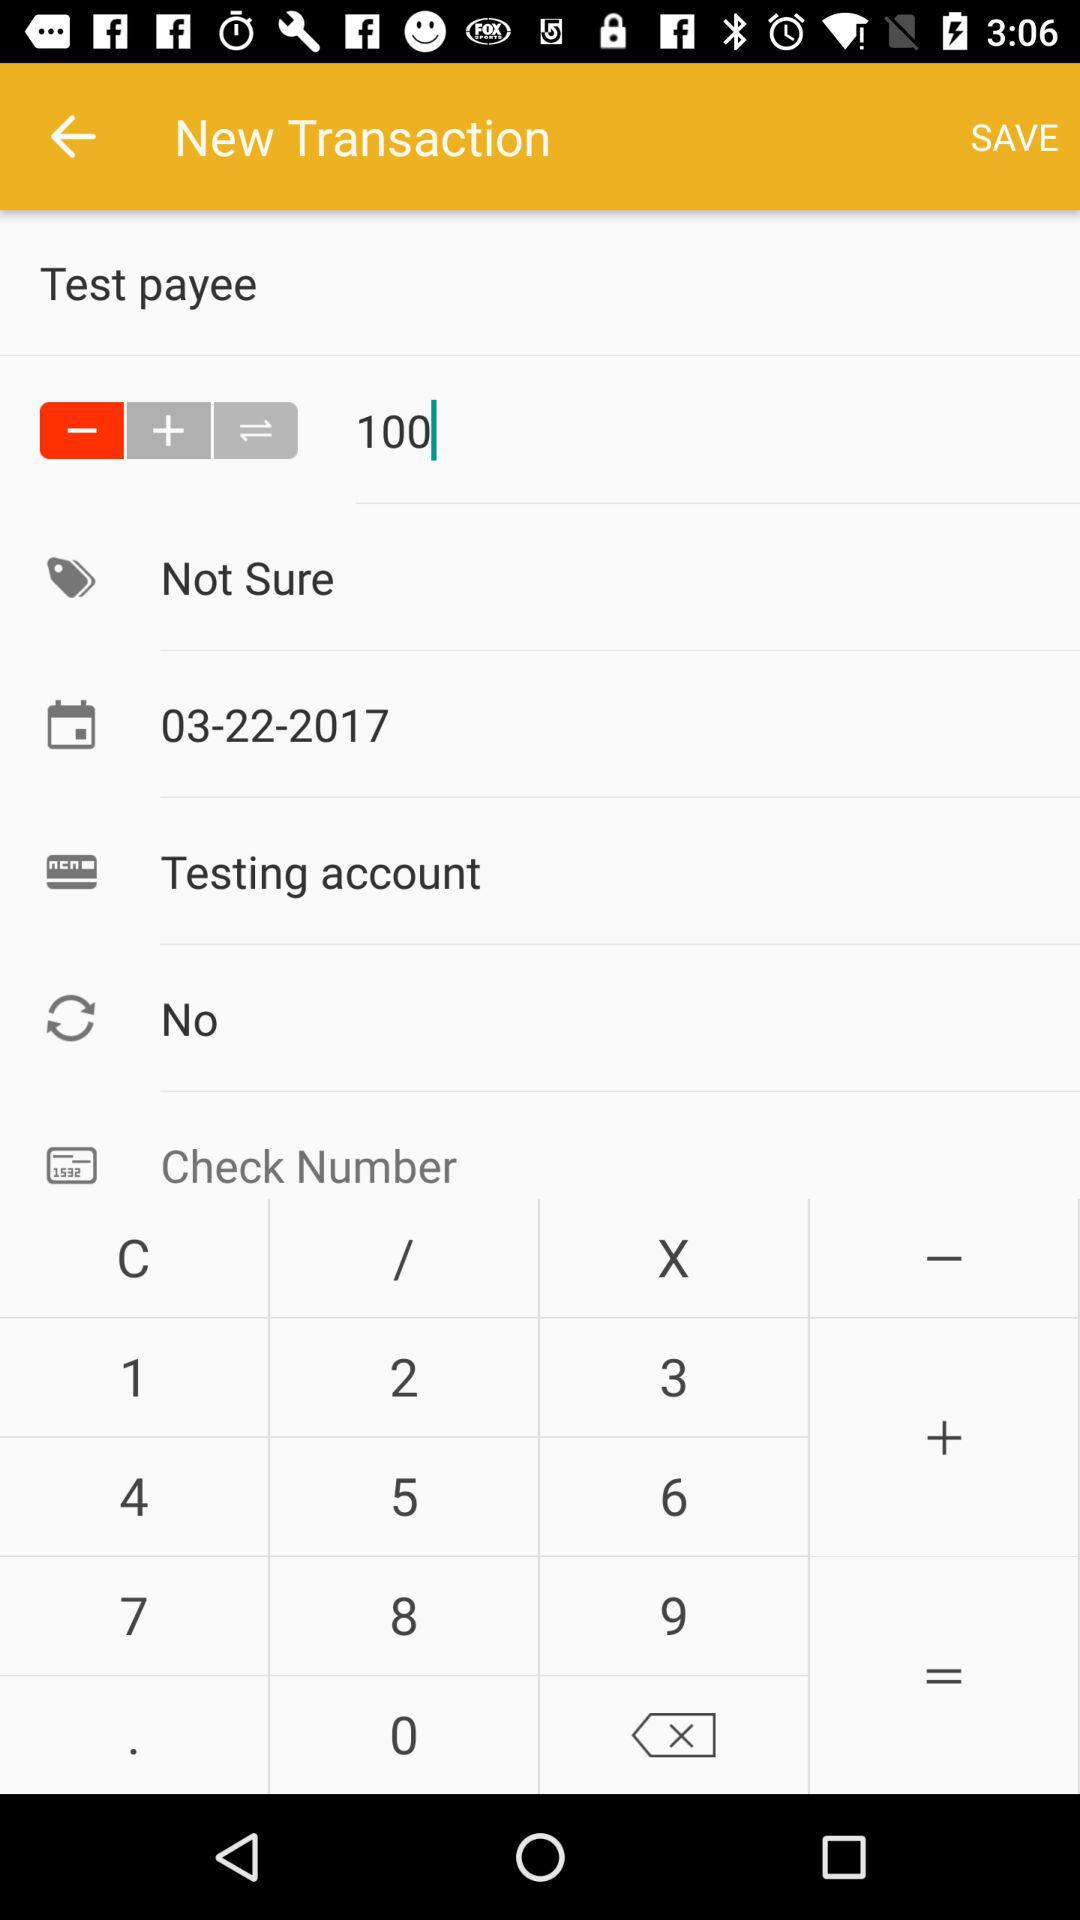What is the date? The date is March 22, 2017. 